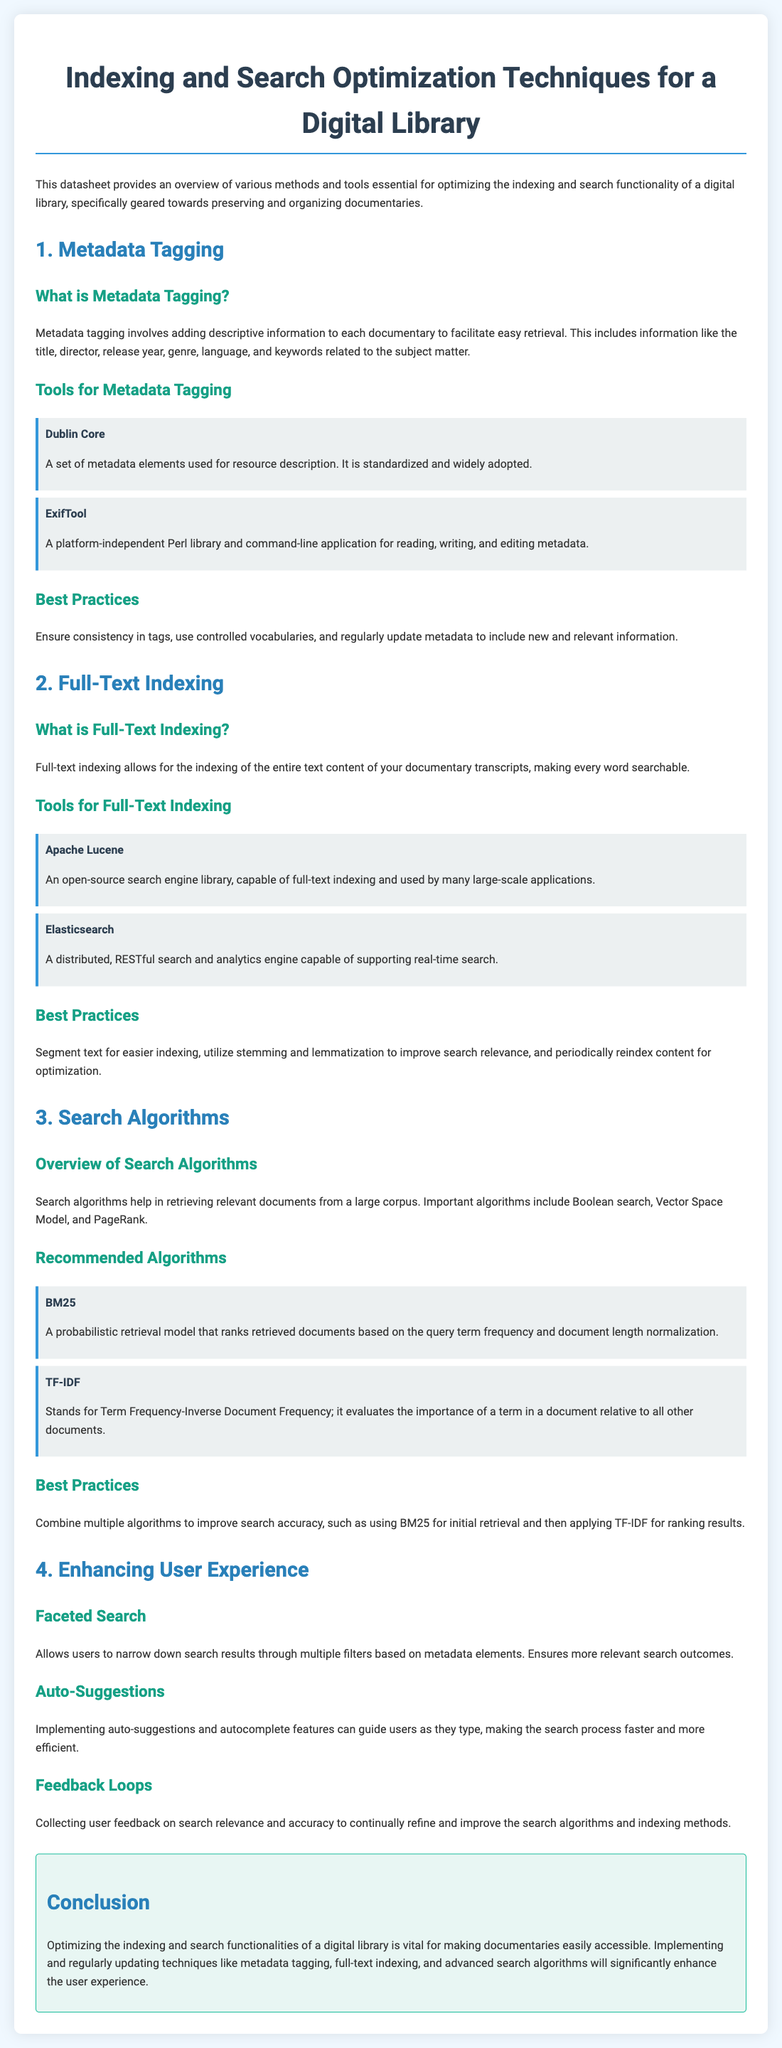What is the title of the datasheet? The title is prominently displayed at the top of the document, which gives an overview of its content.
Answer: Indexing and Search Optimization Techniques for a Digital Library What is the primary purpose of metadata tagging? Metadata tagging is described in the document as a method to facilitate easy retrieval of documentaries by adding descriptive information.
Answer: Facilitate easy retrieval Which tool is mentioned for reading and editing metadata? The document lists specific tools for metadata tagging, including their purposes and usage.
Answer: ExifTool What does BM25 stand for? The document explains that BM25 is a retrieval model used among other algorithms in search optimization.
Answer: BM25 What is one of the best practices for full-text indexing? The document provides a set of best practices under the full-text indexing section for optimizing search functionality.
Answer: Segment text for easier indexing What type of search does faceted search allow? The document describes faceted search as a method that allows users to filter search results based on certain criteria.
Answer: Narrow down search results What algorithm evaluates term importance relative to other documents? The document lists algorithms and their descriptions in the search algorithms section, highlighting their functions and purposes.
Answer: TF-IDF How often should metadata be updated according to best practices? The document provides recommendations for maintaining effective metadata.
Answer: Regularly What is the color theme of the document? The design choices made in the document include specific color schemes detailed in the styling section.
Answer: Blue and white 